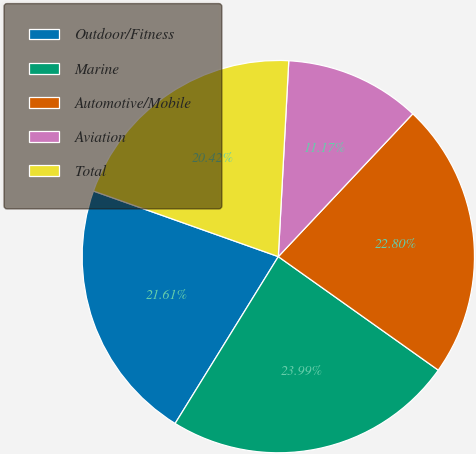<chart> <loc_0><loc_0><loc_500><loc_500><pie_chart><fcel>Outdoor/Fitness<fcel>Marine<fcel>Automotive/Mobile<fcel>Aviation<fcel>Total<nl><fcel>21.61%<fcel>23.99%<fcel>22.8%<fcel>11.17%<fcel>20.42%<nl></chart> 